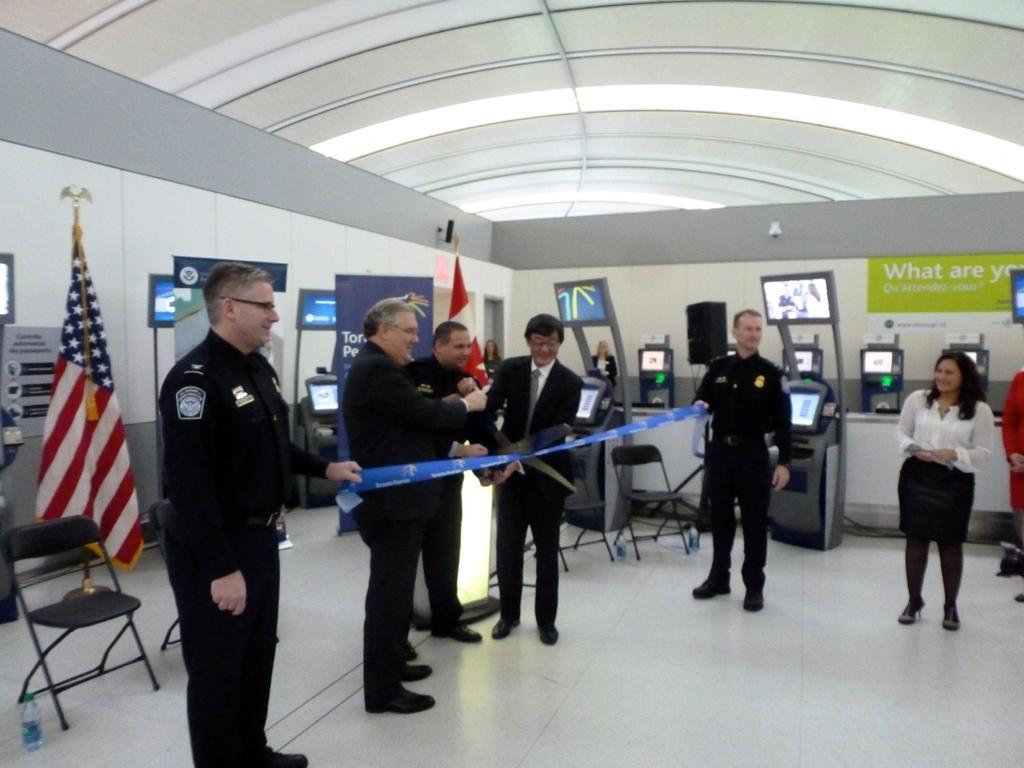Can you describe this image briefly? In this image we can see the person standing on the floor and holding the blue color ribbon. We can also see the persons holding the big scissor. There is also a woman on the right standing and smiling. In the background we can see the machines, banners with text and also the flags and some empty chairs. We can also see the wall and also the ceiling for shelter. On the left there is a water bottle on the floor. 